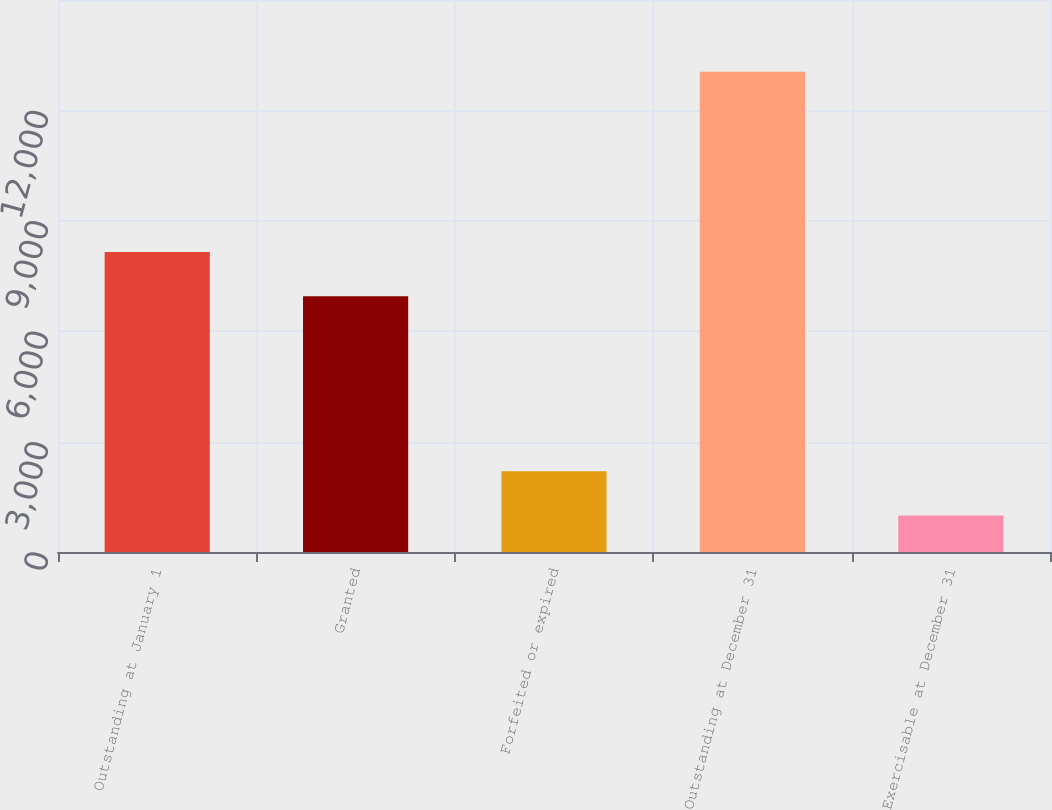Convert chart. <chart><loc_0><loc_0><loc_500><loc_500><bar_chart><fcel>Outstanding at January 1<fcel>Granted<fcel>Forfeited or expired<fcel>Outstanding at December 31<fcel>Exercisable at December 31<nl><fcel>8155.4<fcel>6949<fcel>2195.4<fcel>13053<fcel>989<nl></chart> 